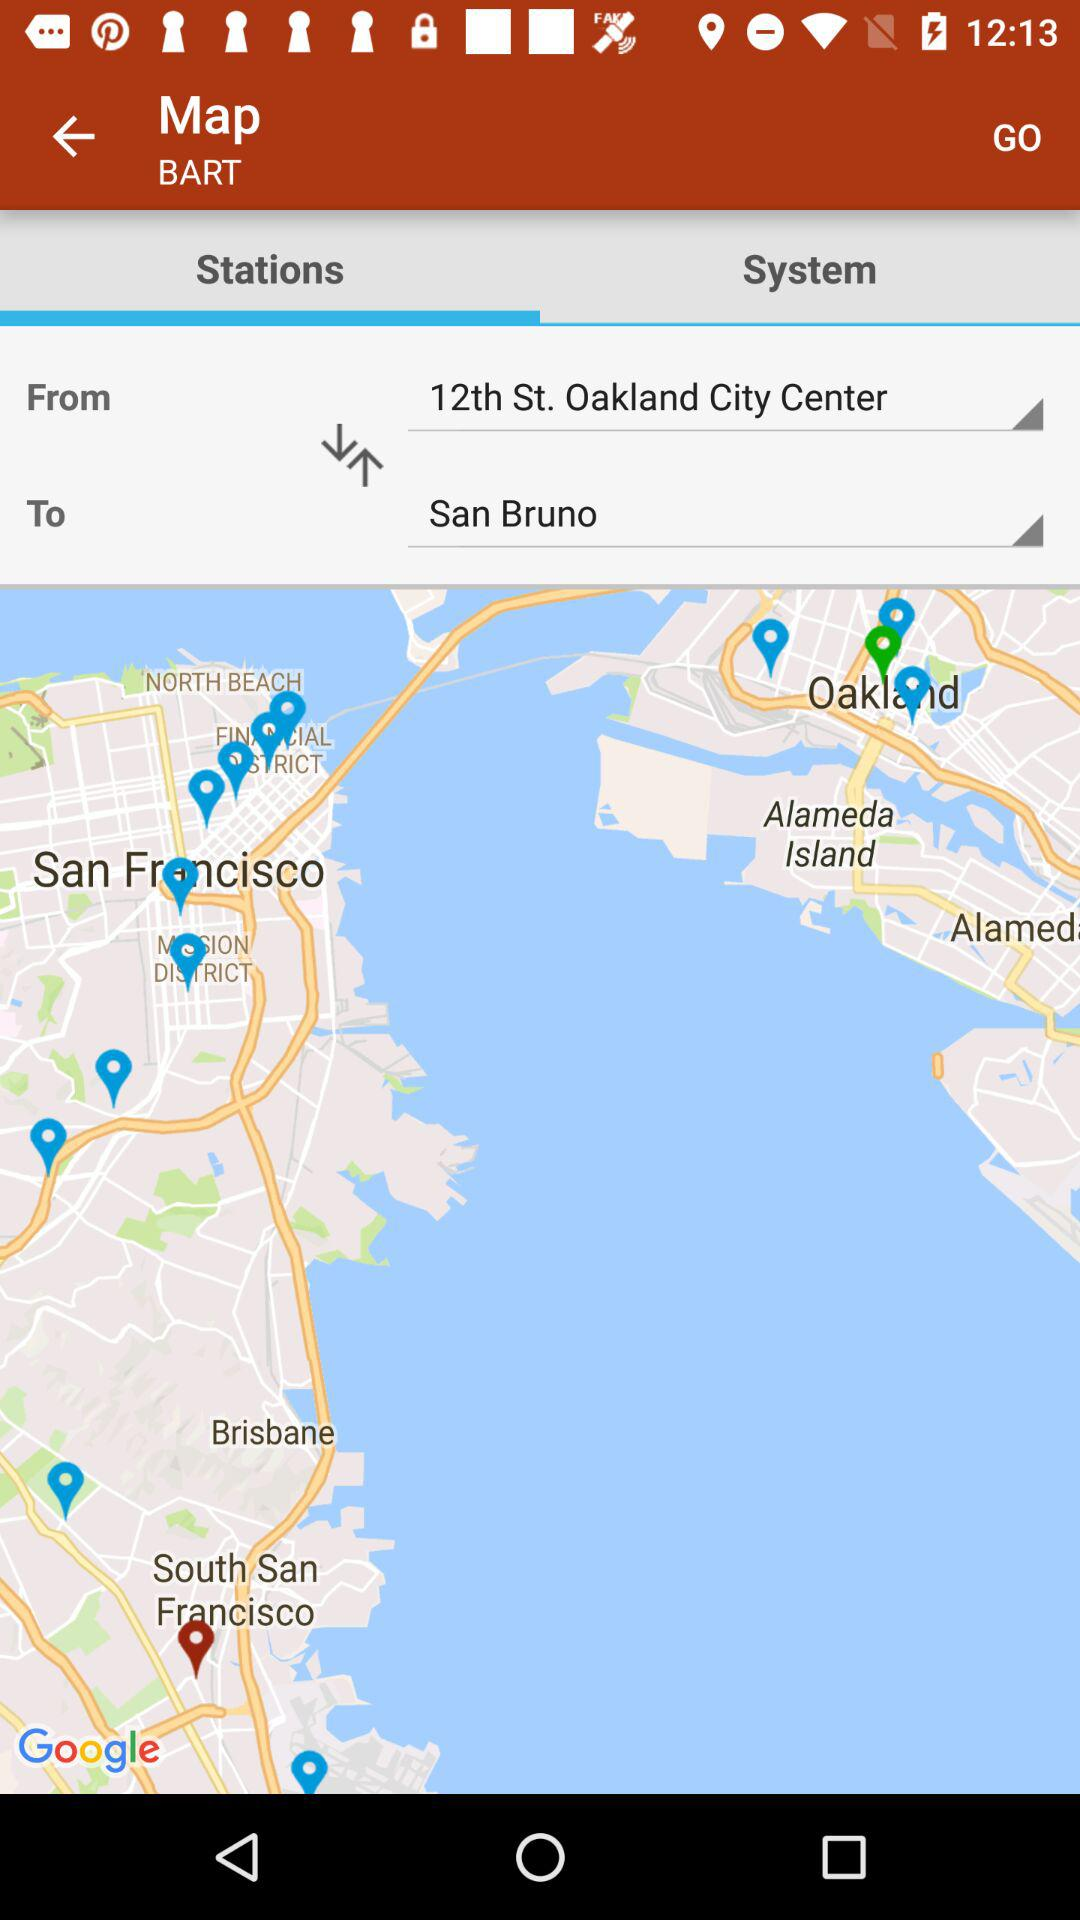Which tab is selected? The selected tab is "Stations". 